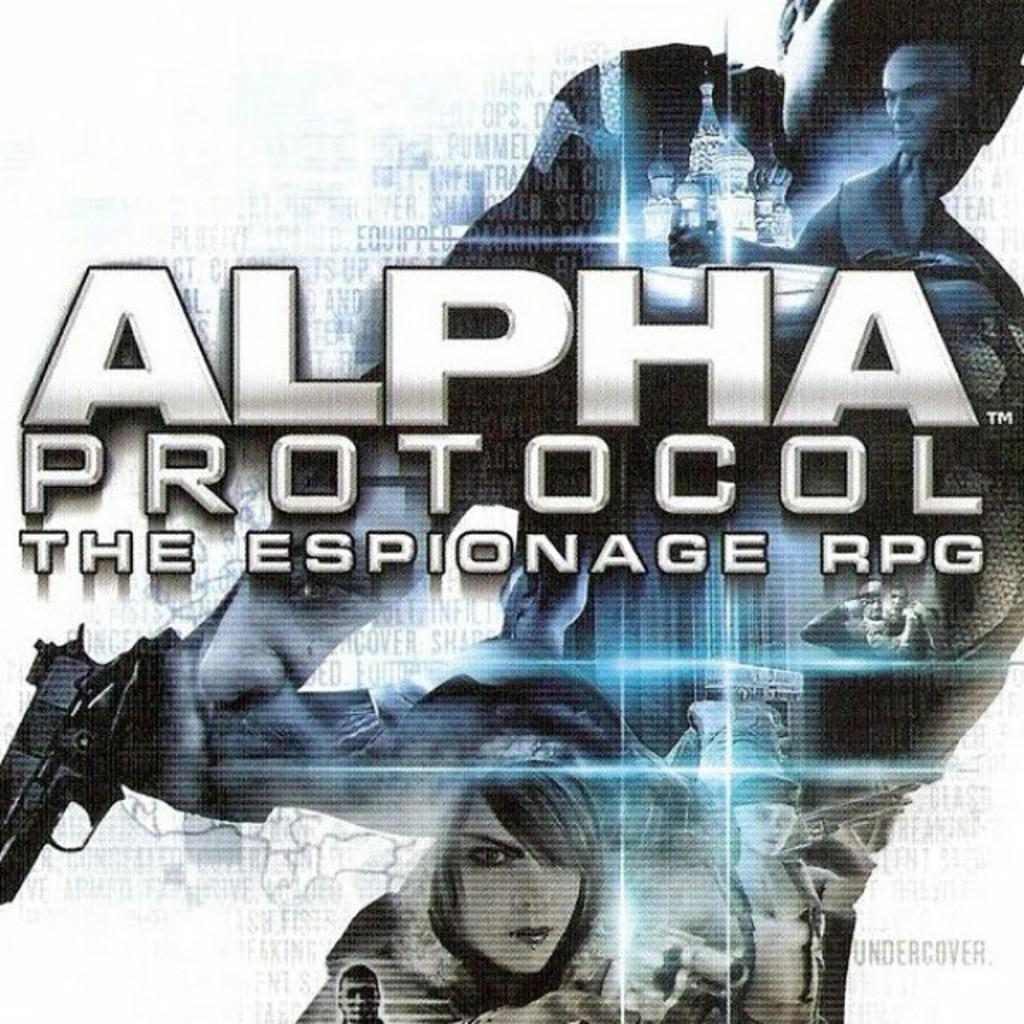What is present on the poster in the image? There is a poster in the image. What can be found on the poster besides images? The poster contains text. What type of appliance can be seen in the image? There is no appliance present in the image. How many thumbs are visible on the poster in the image? There is no thumb visible on the poster in the image. 